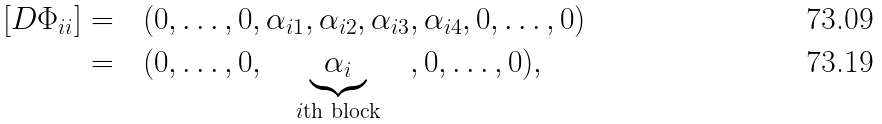Convert formula to latex. <formula><loc_0><loc_0><loc_500><loc_500>[ D \Phi _ { i i } ] = & \quad ( 0 , \dots , 0 , \alpha _ { i 1 } , \alpha _ { i 2 } , \alpha _ { i 3 } , \alpha _ { i 4 } , 0 , \dots , 0 ) \\ = & \quad ( 0 , \dots , 0 , \quad \underbrace { \alpha _ { i } } _ { i \text {th block} } \quad , 0 , \dots , 0 ) ,</formula> 